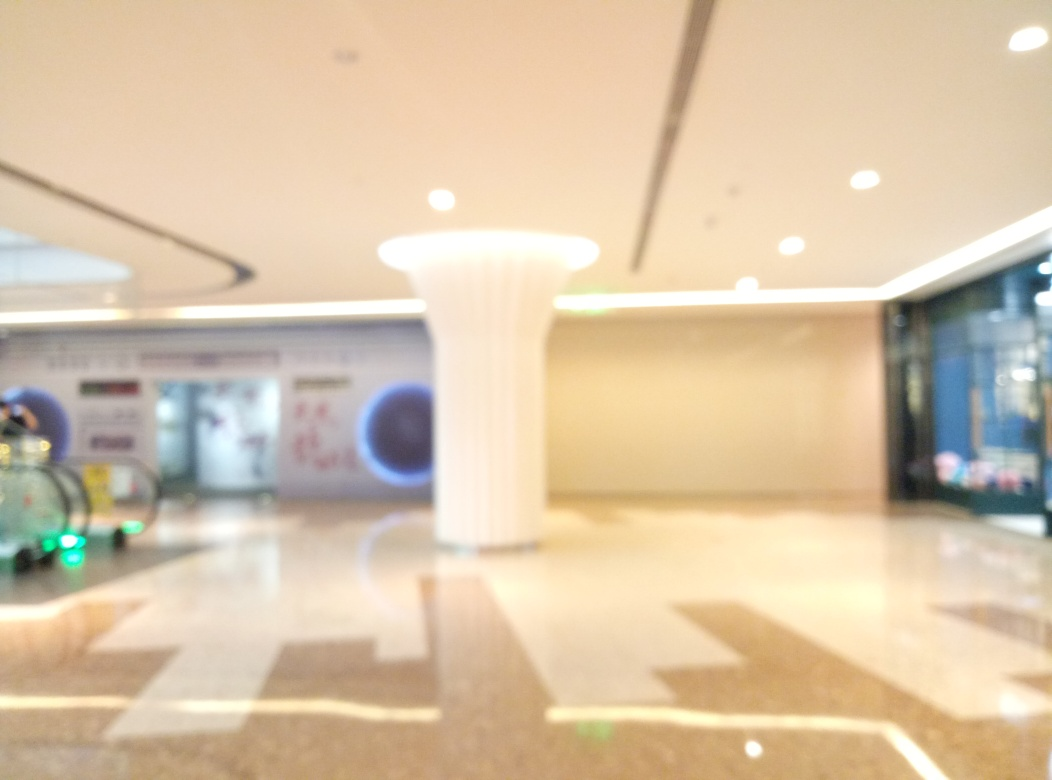Does the image look sharp? The image is not sharp; it appears blurred, possibly due to camera movement, incorrect focus, or a deliberate artistic choice. The lack of sharpness affects the visibility of details. The camera might not have been focused correctly on the subjects, or it could be an effect chosen by the photographer to convey a specific mood or style. 